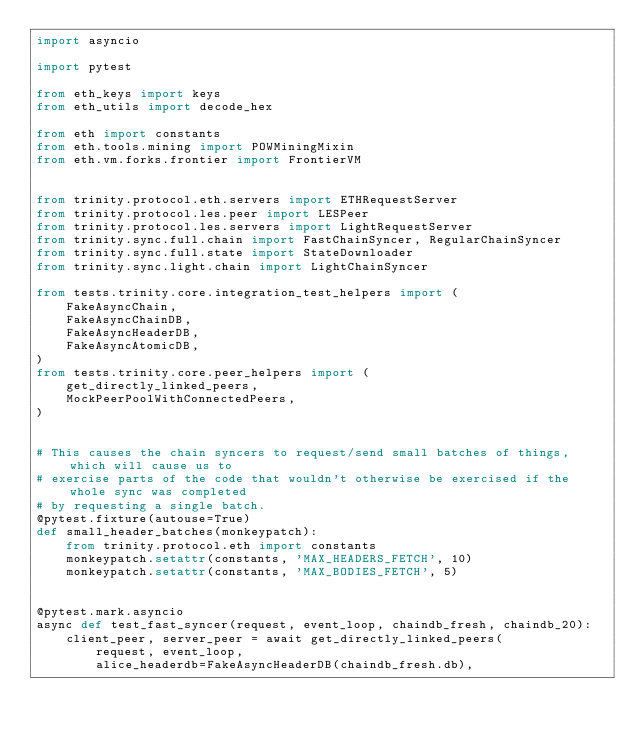<code> <loc_0><loc_0><loc_500><loc_500><_Python_>import asyncio

import pytest

from eth_keys import keys
from eth_utils import decode_hex

from eth import constants
from eth.tools.mining import POWMiningMixin
from eth.vm.forks.frontier import FrontierVM


from trinity.protocol.eth.servers import ETHRequestServer
from trinity.protocol.les.peer import LESPeer
from trinity.protocol.les.servers import LightRequestServer
from trinity.sync.full.chain import FastChainSyncer, RegularChainSyncer
from trinity.sync.full.state import StateDownloader
from trinity.sync.light.chain import LightChainSyncer

from tests.trinity.core.integration_test_helpers import (
    FakeAsyncChain,
    FakeAsyncChainDB,
    FakeAsyncHeaderDB,
    FakeAsyncAtomicDB,
)
from tests.trinity.core.peer_helpers import (
    get_directly_linked_peers,
    MockPeerPoolWithConnectedPeers,
)


# This causes the chain syncers to request/send small batches of things, which will cause us to
# exercise parts of the code that wouldn't otherwise be exercised if the whole sync was completed
# by requesting a single batch.
@pytest.fixture(autouse=True)
def small_header_batches(monkeypatch):
    from trinity.protocol.eth import constants
    monkeypatch.setattr(constants, 'MAX_HEADERS_FETCH', 10)
    monkeypatch.setattr(constants, 'MAX_BODIES_FETCH', 5)


@pytest.mark.asyncio
async def test_fast_syncer(request, event_loop, chaindb_fresh, chaindb_20):
    client_peer, server_peer = await get_directly_linked_peers(
        request, event_loop,
        alice_headerdb=FakeAsyncHeaderDB(chaindb_fresh.db),</code> 